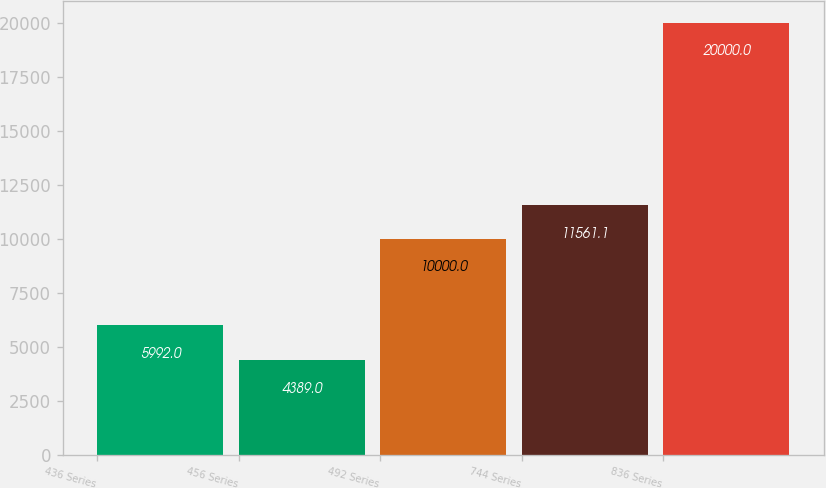Convert chart to OTSL. <chart><loc_0><loc_0><loc_500><loc_500><bar_chart><fcel>436 Series<fcel>456 Series<fcel>492 Series<fcel>744 Series<fcel>836 Series<nl><fcel>5992<fcel>4389<fcel>10000<fcel>11561.1<fcel>20000<nl></chart> 